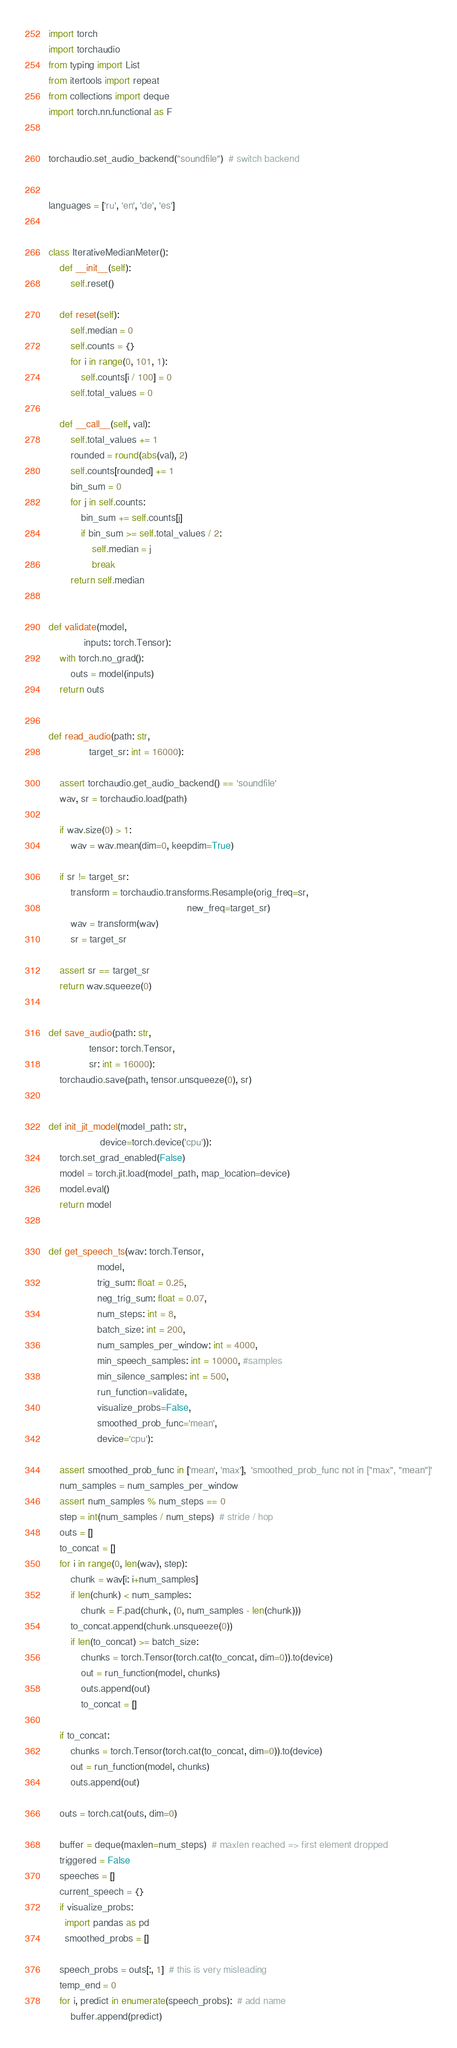<code> <loc_0><loc_0><loc_500><loc_500><_Python_>import torch
import torchaudio
from typing import List
from itertools import repeat
from collections import deque
import torch.nn.functional as F


torchaudio.set_audio_backend("soundfile")  # switch backend


languages = ['ru', 'en', 'de', 'es']


class IterativeMedianMeter():
    def __init__(self):
        self.reset()

    def reset(self):
        self.median = 0
        self.counts = {}
        for i in range(0, 101, 1):
            self.counts[i / 100] = 0
        self.total_values = 0

    def __call__(self, val):
        self.total_values += 1
        rounded = round(abs(val), 2)
        self.counts[rounded] += 1
        bin_sum = 0
        for j in self.counts:
            bin_sum += self.counts[j]
            if bin_sum >= self.total_values / 2:
                self.median = j
                break
        return self.median


def validate(model,
             inputs: torch.Tensor):
    with torch.no_grad():
        outs = model(inputs)
    return outs


def read_audio(path: str,
               target_sr: int = 16000):

    assert torchaudio.get_audio_backend() == 'soundfile'
    wav, sr = torchaudio.load(path)

    if wav.size(0) > 1:
        wav = wav.mean(dim=0, keepdim=True)

    if sr != target_sr:
        transform = torchaudio.transforms.Resample(orig_freq=sr,
                                                   new_freq=target_sr)
        wav = transform(wav)
        sr = target_sr

    assert sr == target_sr
    return wav.squeeze(0)


def save_audio(path: str,
               tensor: torch.Tensor,
               sr: int = 16000):
    torchaudio.save(path, tensor.unsqueeze(0), sr)


def init_jit_model(model_path: str,
                   device=torch.device('cpu')):
    torch.set_grad_enabled(False)
    model = torch.jit.load(model_path, map_location=device)
    model.eval()
    return model


def get_speech_ts(wav: torch.Tensor,
                  model,
                  trig_sum: float = 0.25,
                  neg_trig_sum: float = 0.07,
                  num_steps: int = 8,
                  batch_size: int = 200,
                  num_samples_per_window: int = 4000,
                  min_speech_samples: int = 10000, #samples
                  min_silence_samples: int = 500,
                  run_function=validate,
                  visualize_probs=False,
                  smoothed_prob_func='mean',
                  device='cpu'):

    assert smoothed_prob_func in ['mean', 'max'],  'smoothed_prob_func not in ["max", "mean"]'
    num_samples = num_samples_per_window
    assert num_samples % num_steps == 0
    step = int(num_samples / num_steps)  # stride / hop
    outs = []
    to_concat = []
    for i in range(0, len(wav), step):
        chunk = wav[i: i+num_samples]
        if len(chunk) < num_samples:
            chunk = F.pad(chunk, (0, num_samples - len(chunk)))
        to_concat.append(chunk.unsqueeze(0))
        if len(to_concat) >= batch_size:
            chunks = torch.Tensor(torch.cat(to_concat, dim=0)).to(device)
            out = run_function(model, chunks)
            outs.append(out)
            to_concat = []

    if to_concat:
        chunks = torch.Tensor(torch.cat(to_concat, dim=0)).to(device)
        out = run_function(model, chunks)
        outs.append(out)

    outs = torch.cat(outs, dim=0)

    buffer = deque(maxlen=num_steps)  # maxlen reached => first element dropped
    triggered = False
    speeches = []
    current_speech = {}
    if visualize_probs:
      import pandas as pd
      smoothed_probs = []

    speech_probs = outs[:, 1]  # this is very misleading
    temp_end = 0
    for i, predict in enumerate(speech_probs):  # add name
        buffer.append(predict)</code> 